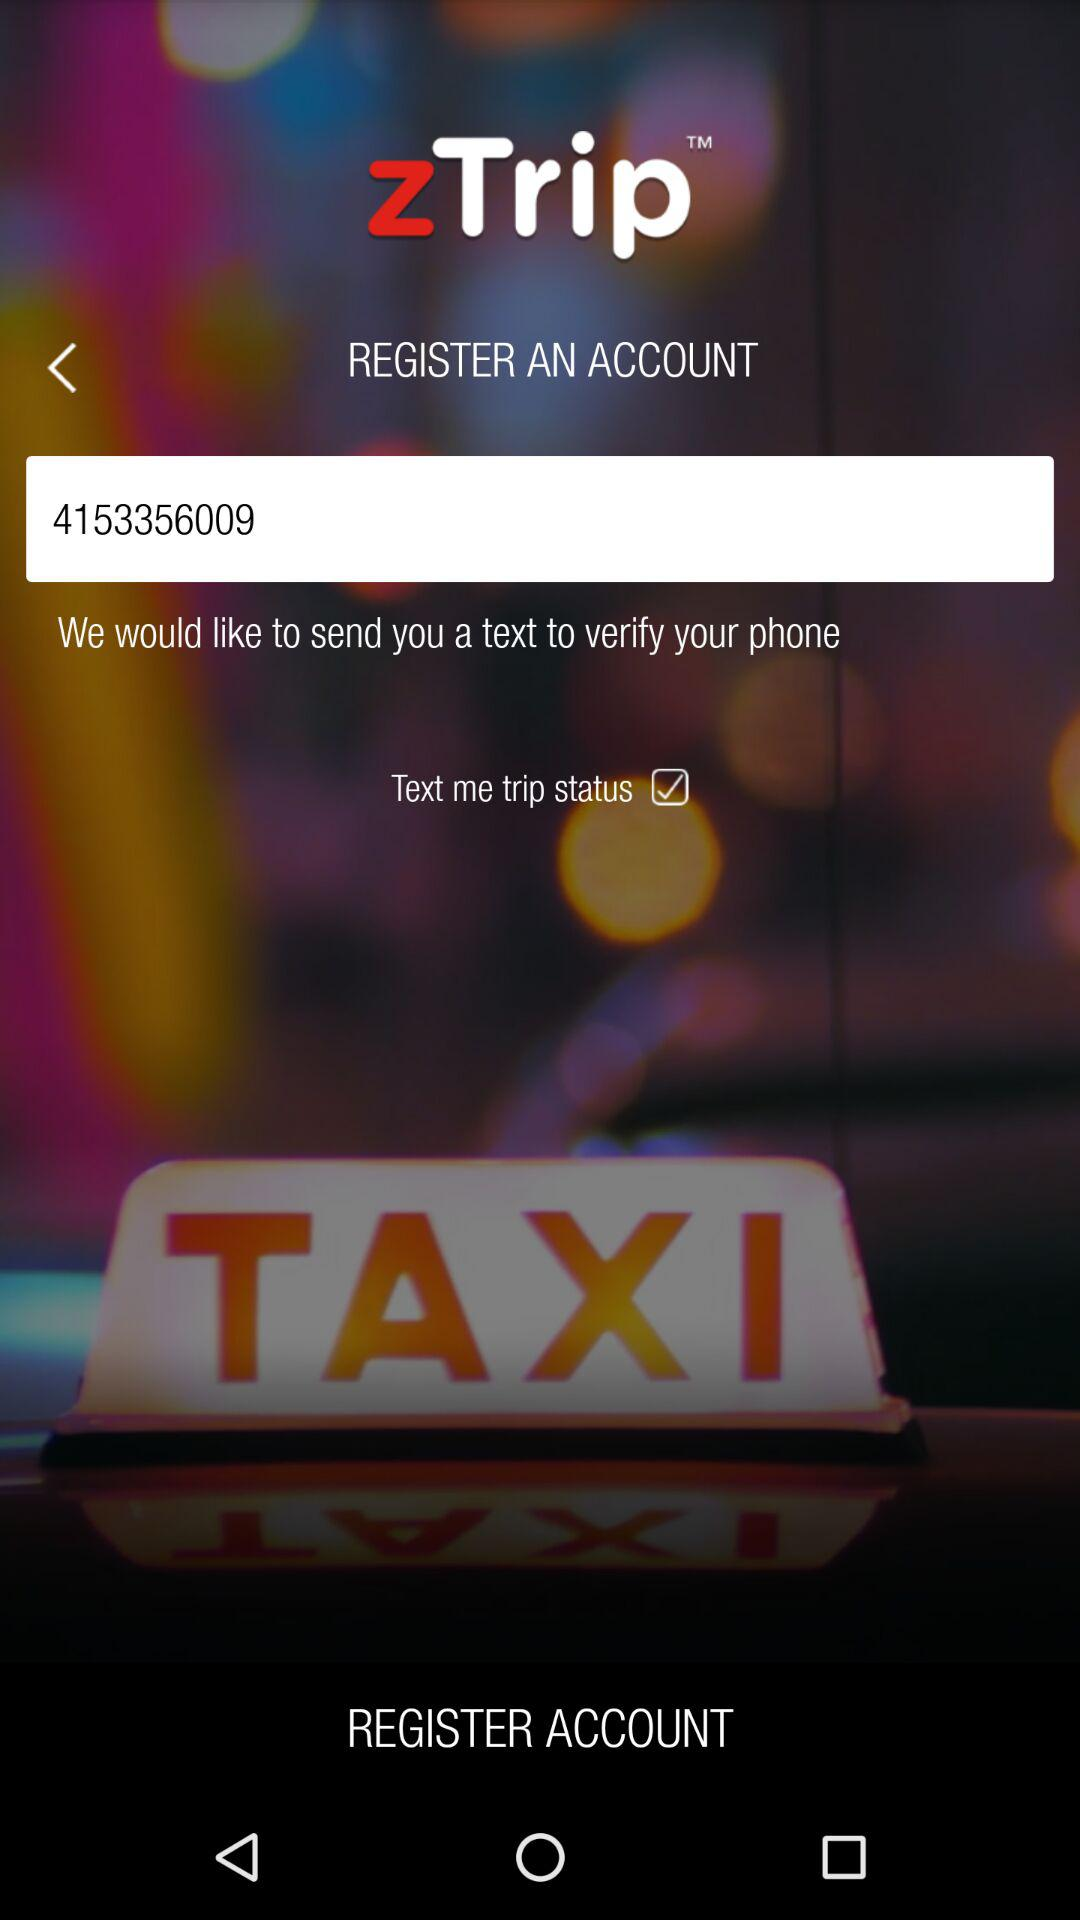What is the version of this application?
When the provided information is insufficient, respond with <no answer>. <no answer> 